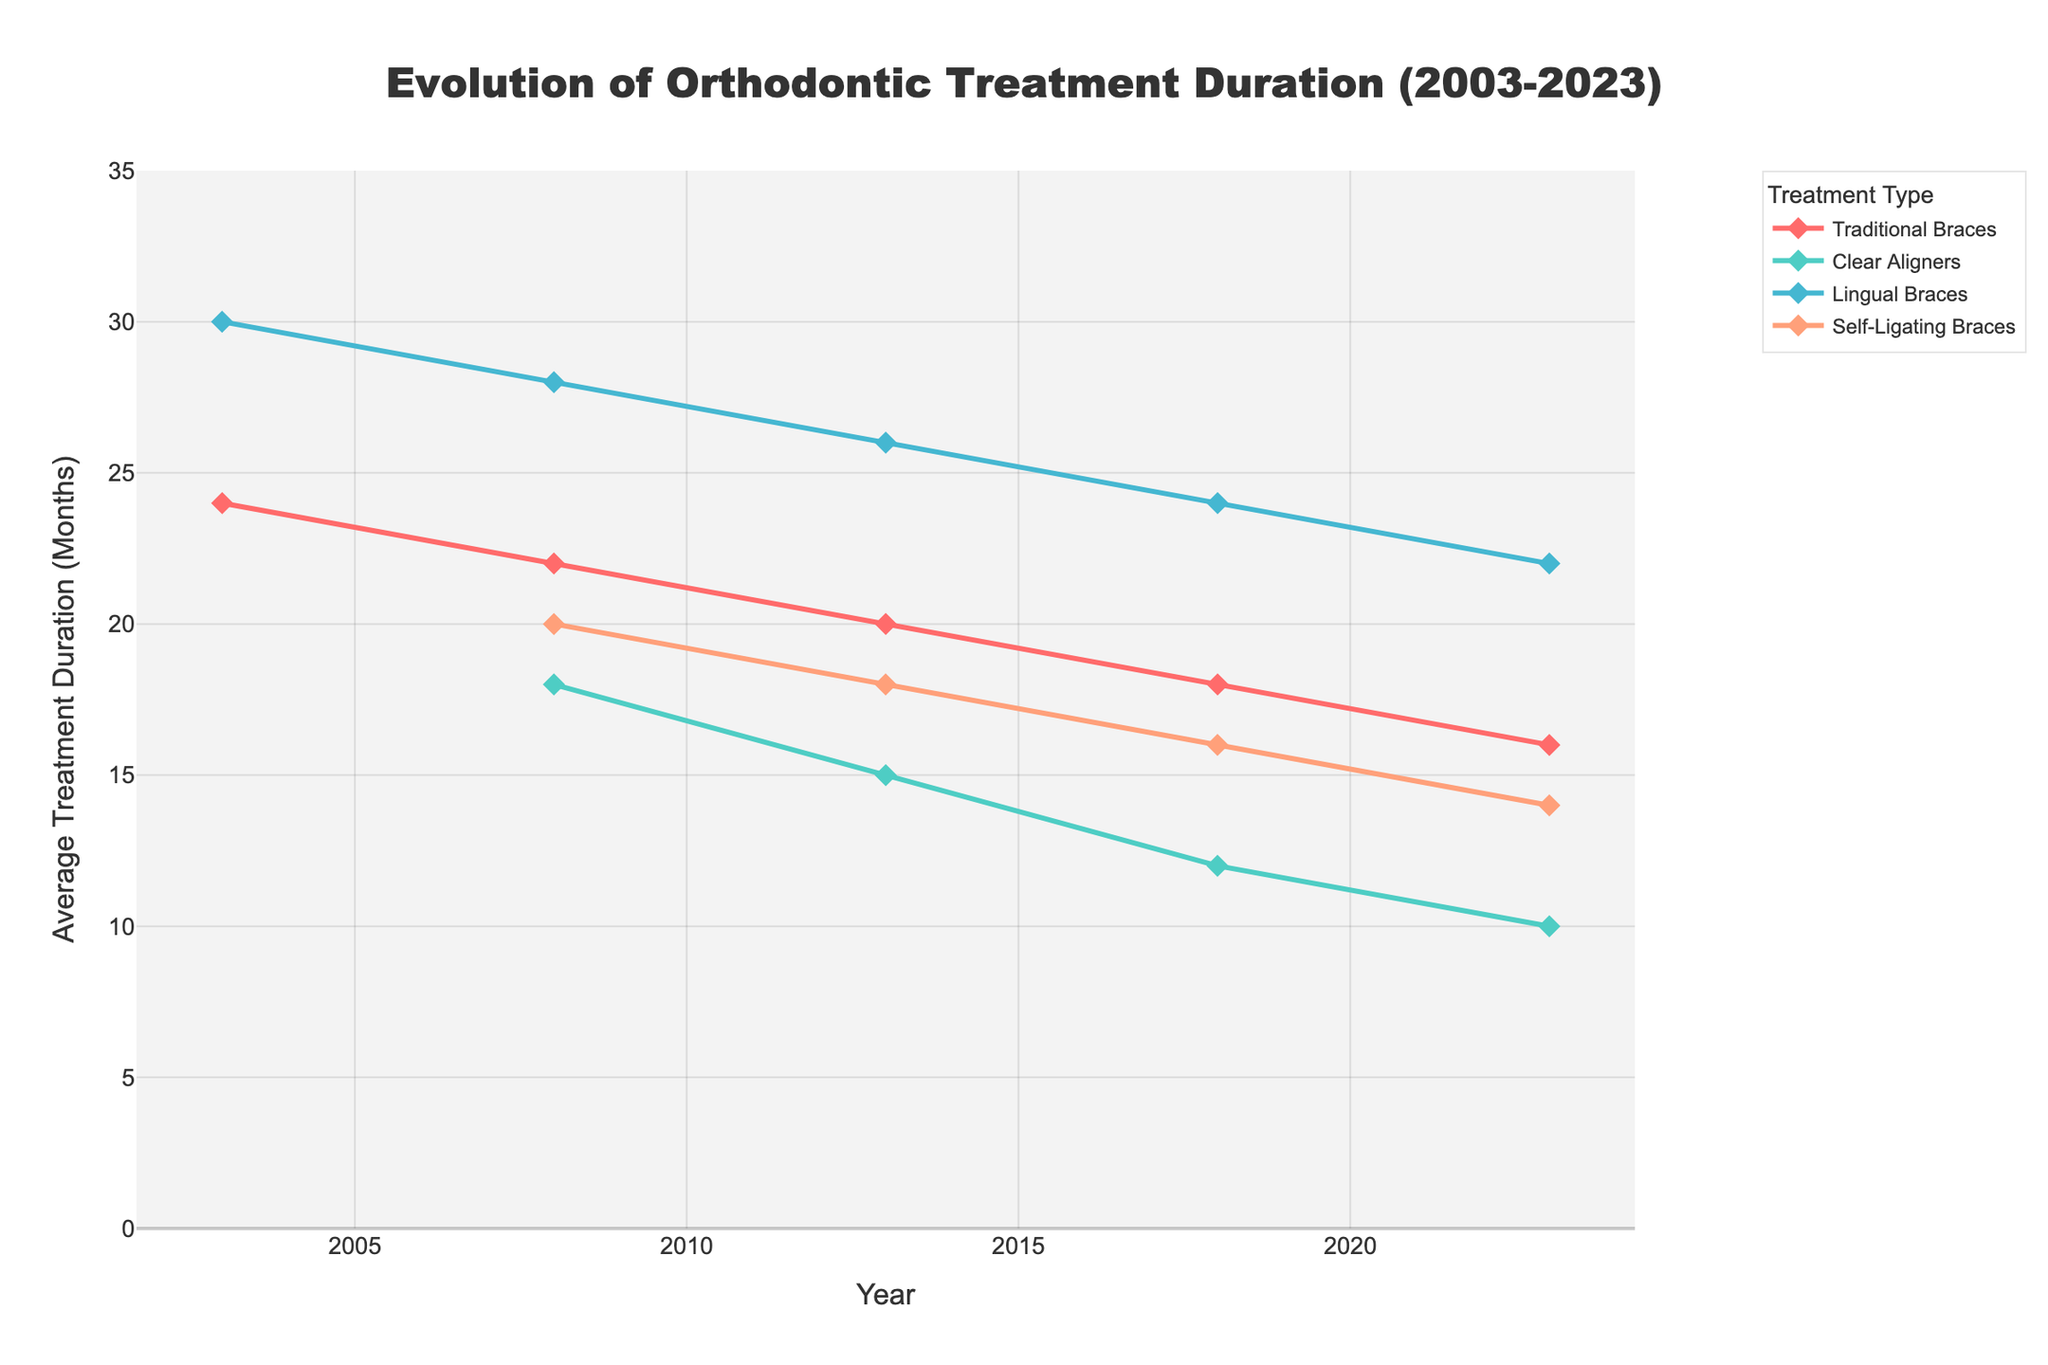What is the overall trend in the treatment duration for Clear Aligners from 2008 to 2023? The line for Clear Aligners decreases steadily from 18 months in 2008 to 10 months in 2023, indicating a reduction in treatment duration over the years.
Answer: Decreasing trend Which treatment type had the longest average treatment duration in 2003? In 2003, Lingual Braces had the longest treatment duration, with a value of 30 months.
Answer: Lingual Braces By how many months did the treatment duration for Self-Ligating Braces decrease between 2008 to 2023? In 2008, the treatment duration for Self-Ligating Braces is 20 months, and in 2023 it is 14 months. The decrease is 20 - 14 = 6 months.
Answer: 6 months Compare the changes in the average treatment duration for Traditional Braces and Clear Aligners between 2013 and 2023. For Traditional Braces, the duration decreased from 20 to 16 months, a reduction of 4 months. For Clear Aligners, the duration decreased from 15 to 10 months, a reduction of 5 months.
Answer: Traditional Braces: 4 months, Clear Aligners: 5 months What is the average treatment duration for Lingual Braces across the displayed years? The durations for Lingual Braces are 30, 28, 26, 24, and 22 months. Summing them: 30 + 28 + 26 + 24 + 22 = 130 months. The average is 130 / 5 = 26 months.
Answer: 26 months Which treatment type saw the most significant reduction in treatment duration over the full 20-year period? Clear Aligners reduced from 18 months in 2008 to 10 months in 2023, a reduction of 8 months. This is the most significant reduction among the treatments.
Answer: Clear Aligners In which year did Self-Ligating Braces have a treatment duration equal to the 2013 duration for Clear Aligners? In 2013, Clear Aligners had a duration of 15 months. Self-Ligating Braces had the same duration in 2008.
Answer: 2008 What is the difference in the average treatment duration between Lingual Braces and Traditional Braces in 2023? In 2023, Lingual Braces have a duration of 22 months, and Traditional Braces have a duration of 16 months. The difference is 22 - 16 = 6 months.
Answer: 6 months Which treatment type was introduced into the figure's dataset after 2003 and showed a nearly continuous decrease in duration? Clear Aligners were introduced in 2008 with a duration of 18 months. The duration decreased continuously to 10 months by 2023.
Answer: Clear Aligners 